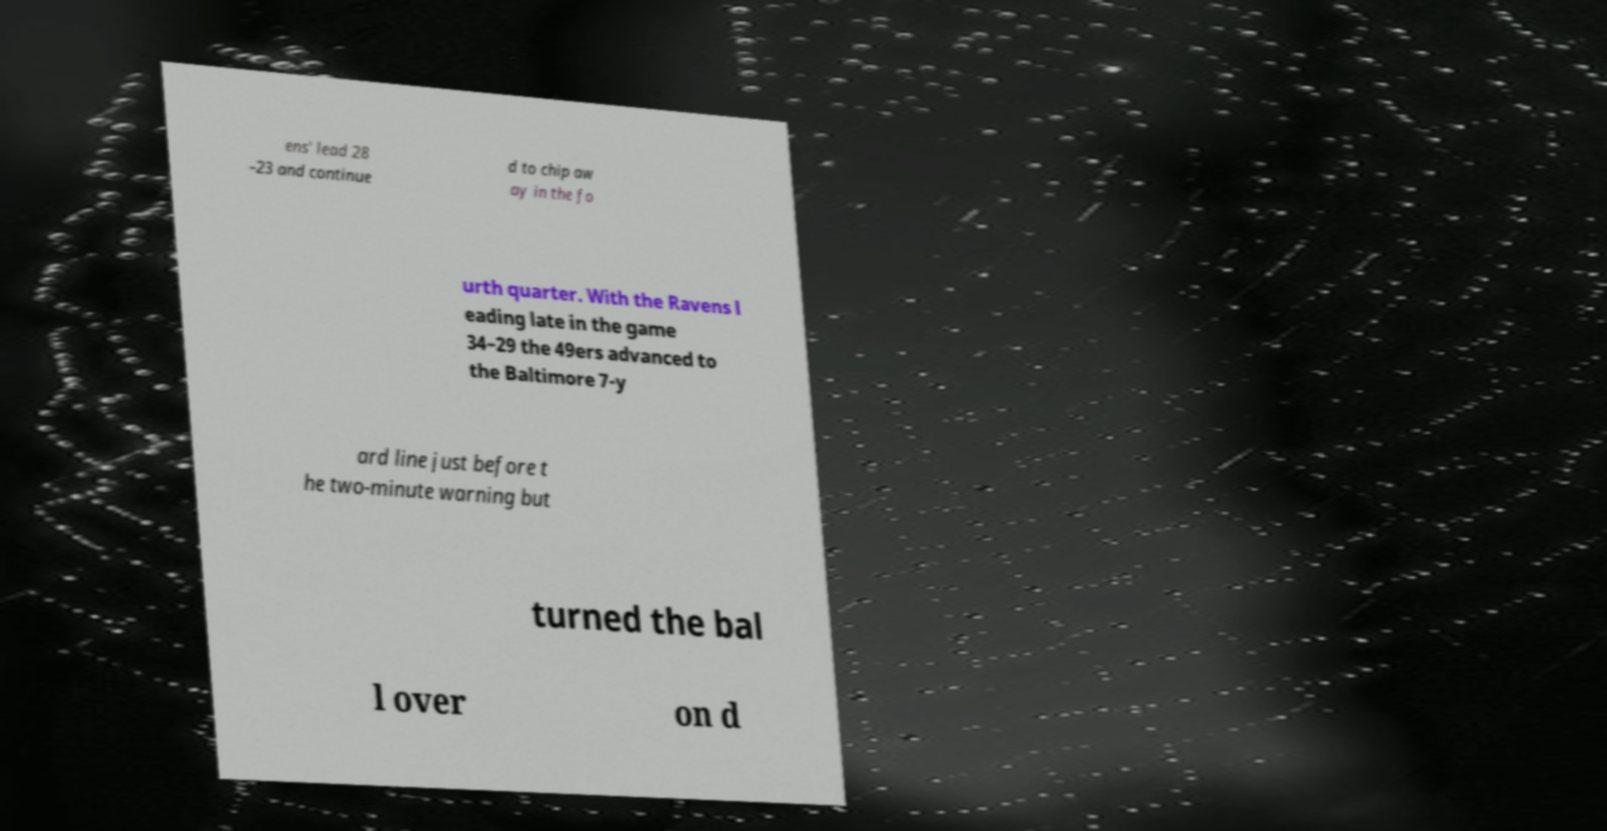Please read and relay the text visible in this image. What does it say? ens' lead 28 –23 and continue d to chip aw ay in the fo urth quarter. With the Ravens l eading late in the game 34–29 the 49ers advanced to the Baltimore 7-y ard line just before t he two-minute warning but turned the bal l over on d 